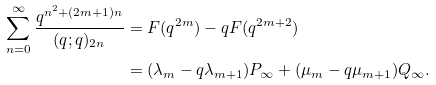Convert formula to latex. <formula><loc_0><loc_0><loc_500><loc_500>\sum _ { n = 0 } ^ { \infty } \frac { q ^ { n ^ { 2 } + ( 2 m + 1 ) n } } { ( q ; q ) _ { 2 n } } & = F ( q ^ { 2 m } ) - q F ( q ^ { 2 m + 2 } ) \\ & = ( \lambda _ { m } - q \lambda _ { m + 1 } ) P _ { \infty } + ( \mu _ { m } - q \mu _ { m + 1 } ) Q _ { \infty } .</formula> 